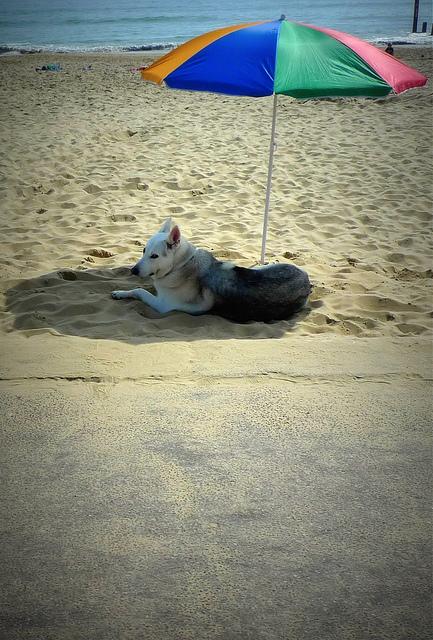Is it too hot for the dog?
Concise answer only. Yes. What kind of dog is this?
Answer briefly. Husky. What colors are on the umbrella?
Answer briefly. Rainbow. 